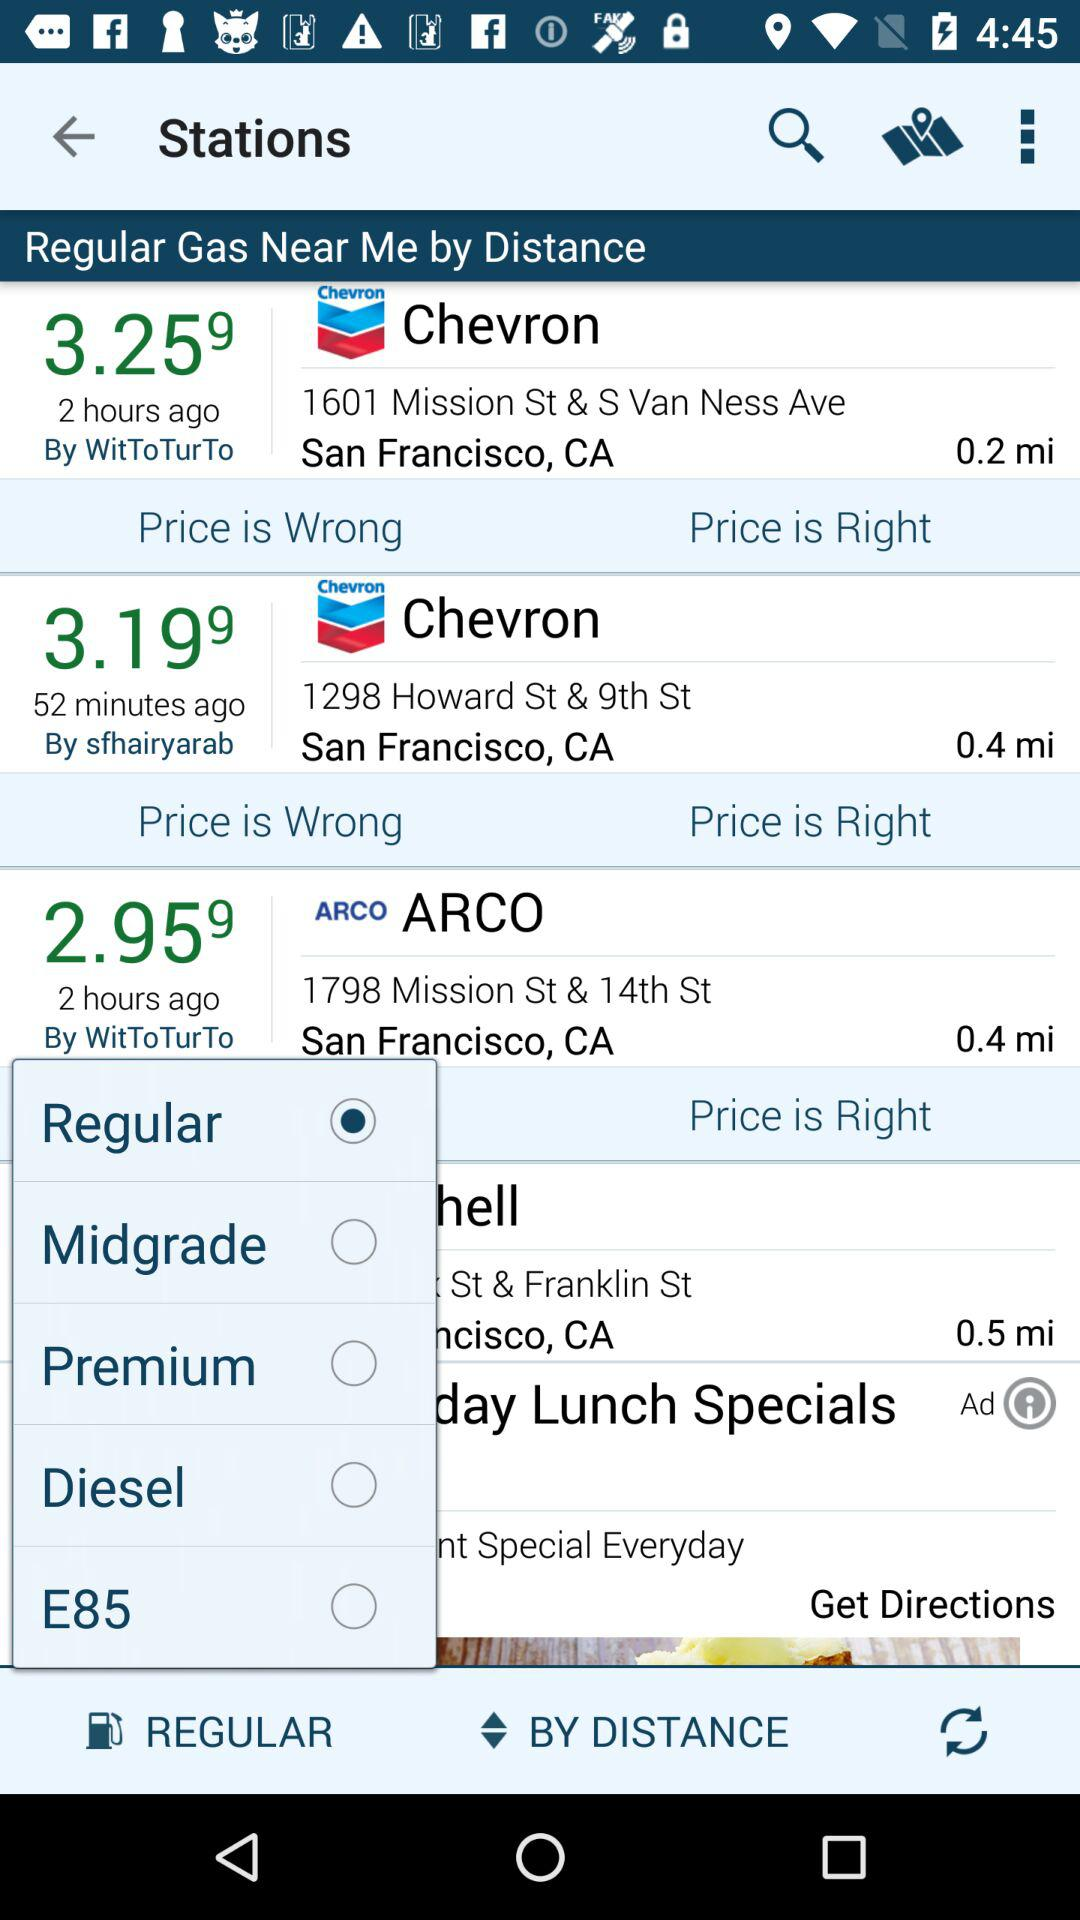How many hours ago did ARCO Gas Station update its status? ARCO Gas Station updated its status 2 hours ago. 